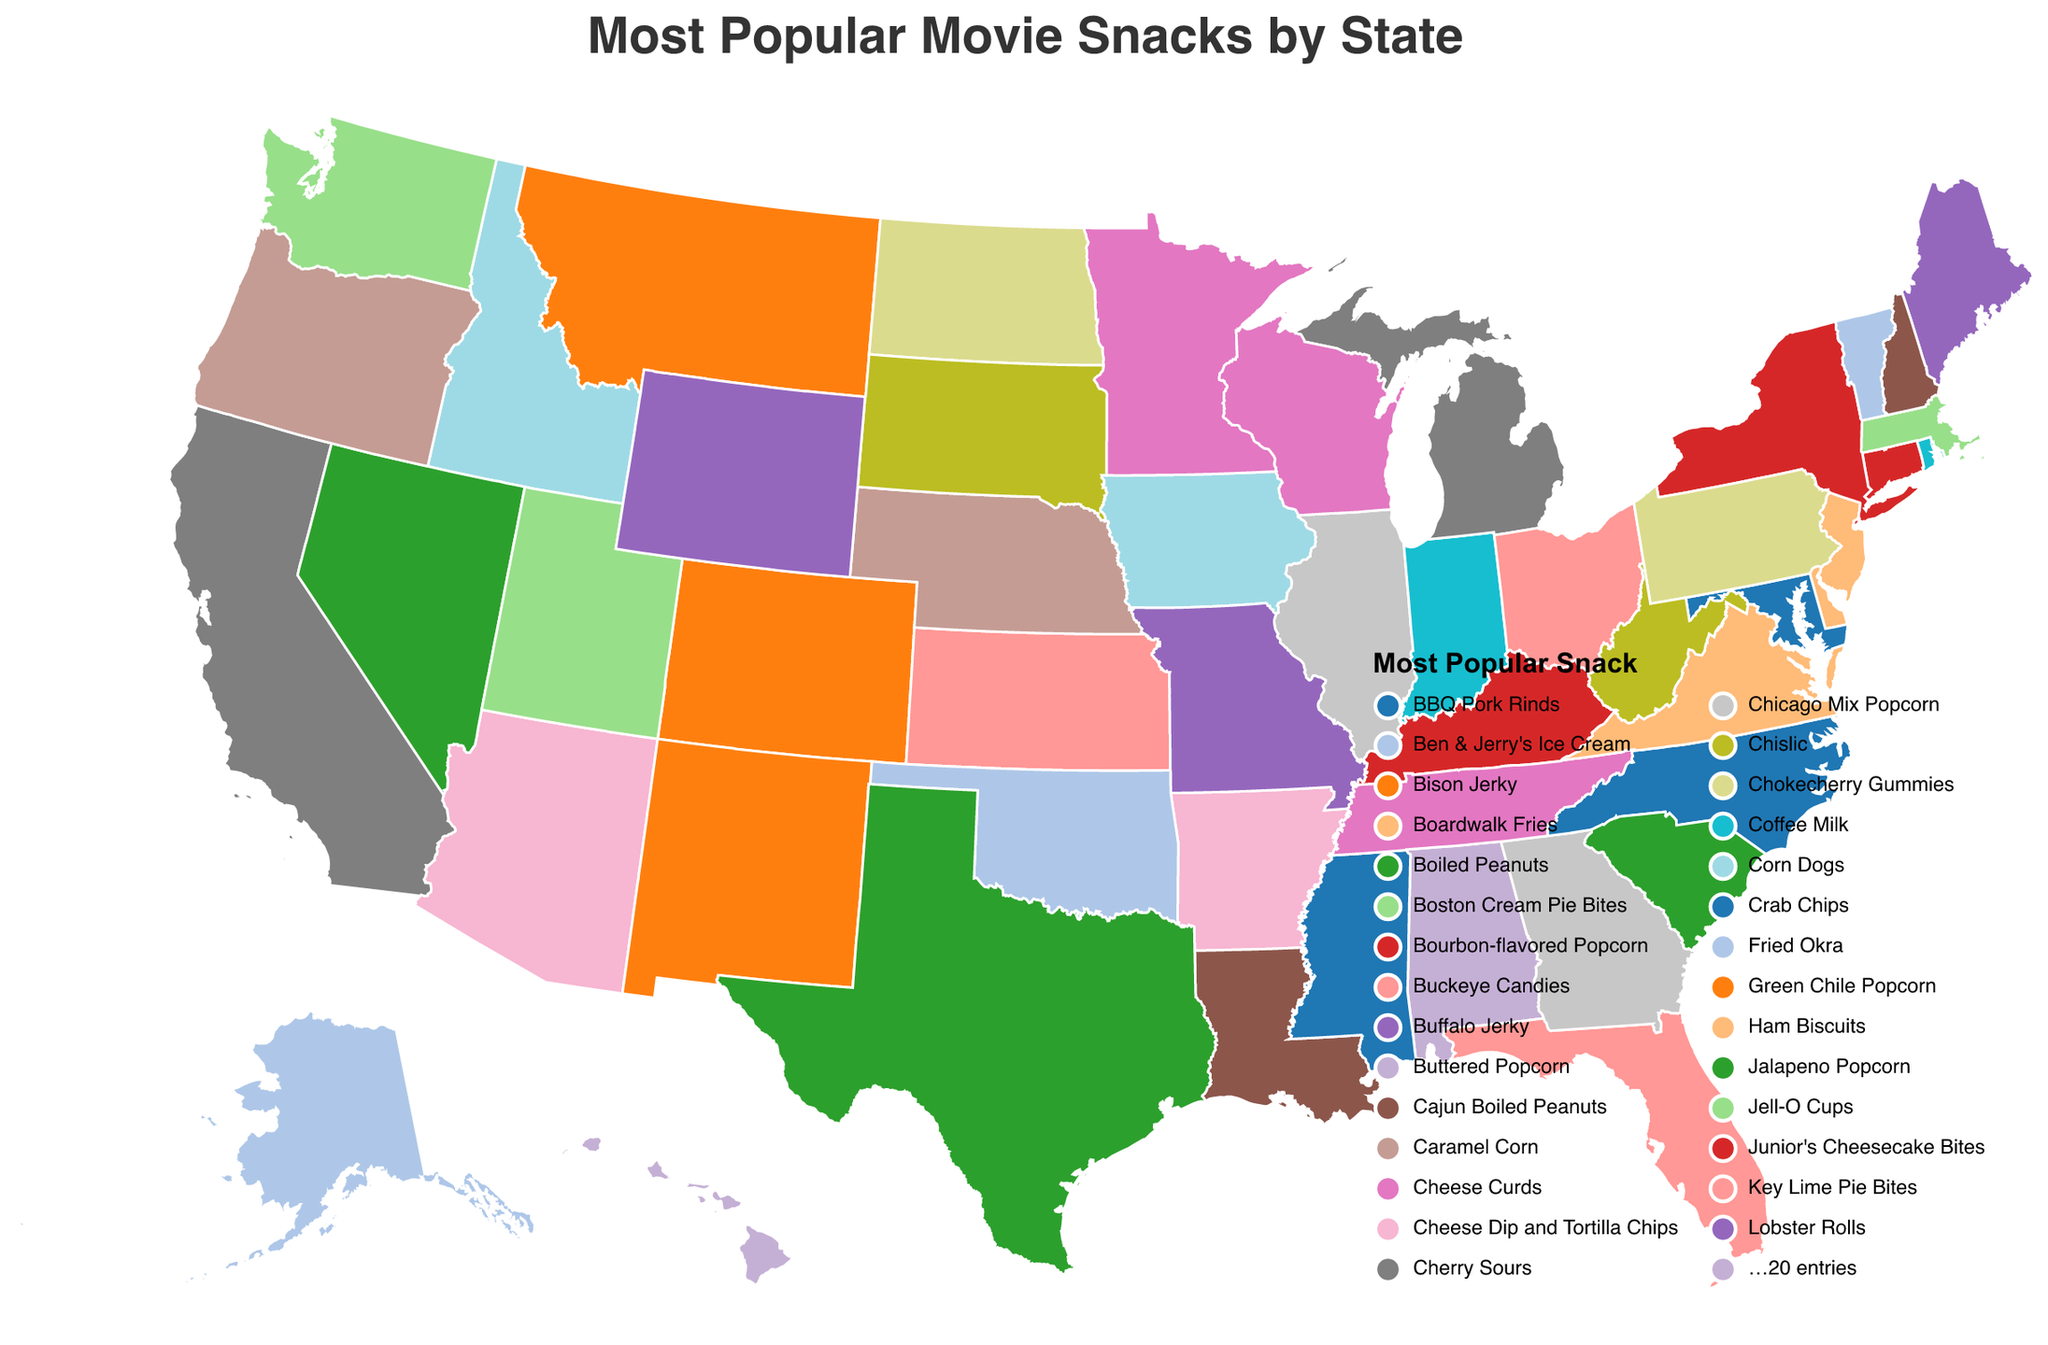What is the most popular movie snack in Texas? To find the answer, locate Texas on the map and refer to the color legend that corresponds to the most popular snack in Texas. This indicates "Jalapeno Popcorn" as the most popular snack in Texas.
Answer: Jalapeno Popcorn Which state prefers Cheese Curds as their movie snack? Locate the text or color on the figure corresponding to "Cheese Curds". Check where that color or label appears on the map; it appears in both Minnesota and Wisconsin.
Answer: Minnesota and Wisconsin What snack is most popular in California and how does it compare to Alaska's favorite? Identify California's most popular snack from the map, which is "Organic Trail Mix", and compare it to Alaska's, which is "Reindeer Sausage Bites".
Answer: California: Organic Trail Mix, Alaska: Reindeer Sausage Bites How many states prefer a type of popcorn? Sum the occurrences of any form of popcorn by identifying their representation on the map: Buttered Popcorn (Alabama), Chicago Mix Popcorn (Illinois), Bourbon-flavored Popcorn (Kentucky), Green Chile Popcorn (New Mexico), Jalapeno Popcorn (Texas). Thus, there are 5 states where some type of popcorn is the favorite.
Answer: 5 Which state has the unique snack of Bison Jerky and where is it located? Look for "Bison Jerky" in the list and its corresponding state Montana on the map to locate it geographically, which is in the northwestern region.
Answer: Montana What is the movie snack representing southern flavors in Louisiana and South Carolina? Look at Louisiana’s and South Carolina's entries on the map; they have "Cajun Boiled Peanuts" and "Boiled Peanuts", respectively, representing southern flavors.
Answer: Louisiana: Cajun Boiled Peanuts, South Carolina: Boiled Peanuts Which state enjoys sweet snacks and another prefers savory snacks and what are they? Identify North Dakota with "Chokecherry Gummies" (sweet) and Delaware with "Boardwalk Fries" (savory) by locating them on the map.
Answer: North Dakota: Chokecherry Gummies, Delaware: Boardwalk Fries Can you find a state with seafood as their movie snack? Observe the map for occurrences of seafood-related snacks: "Shrimp Cocktail" in Nevada and "Smoked Salmon Jerky" in Washington.
Answer: Nevada and Washington What is common between the most popular movie snacks in states like Indiana and Iowa? Compare the movie snacks of Indiana (Popcorn Balls) and Iowa (Corn Dogs); the common factor is corn, suggesting a preference for corn-based snacks.
Answer: Corn-based snacks Which state prefers a traditional sweet snack linked to campfires? Look at the map for a traditional sweet snack related to campfires; Tennessee's "Moon Pies" share a similar heritage.
Answer: Tennessee 